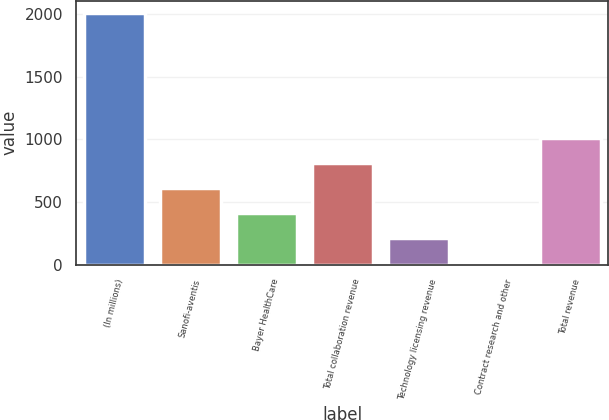<chart> <loc_0><loc_0><loc_500><loc_500><bar_chart><fcel>(In millions)<fcel>Sanofi-aventis<fcel>Bayer HealthCare<fcel>Total collaboration revenue<fcel>Technology licensing revenue<fcel>Contract research and other<fcel>Total revenue<nl><fcel>2007<fcel>608.4<fcel>408.6<fcel>808.2<fcel>208.8<fcel>9<fcel>1008<nl></chart> 